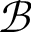<formula> <loc_0><loc_0><loc_500><loc_500>\mathcal { B }</formula> 